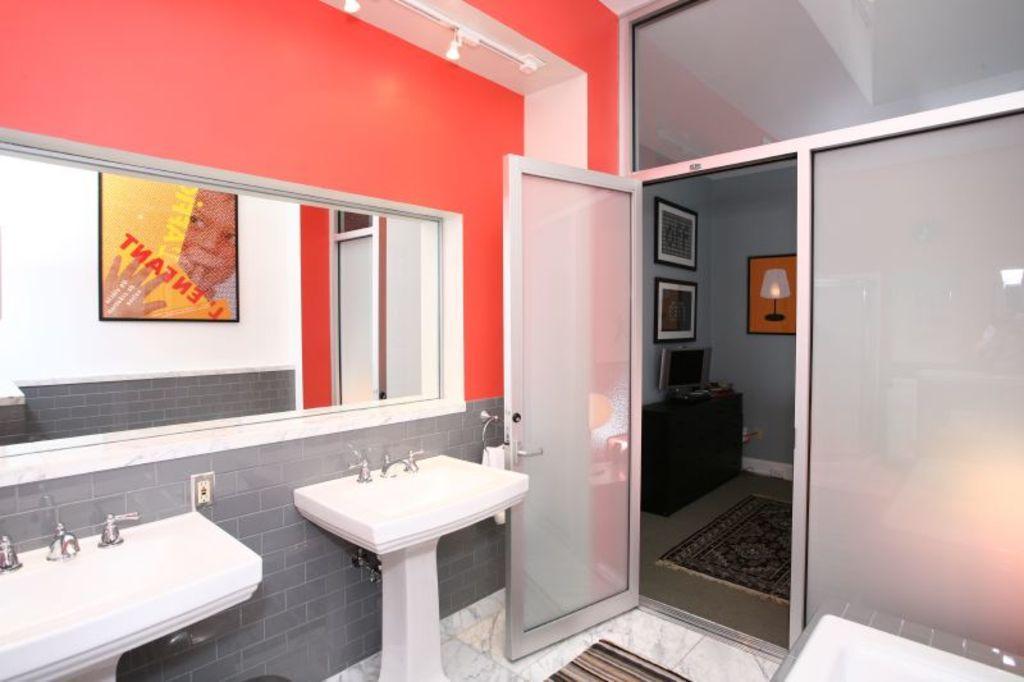Describe this image in one or two sentences. In this picture we can see the wash basin, taps, reflection of a board and the wall. We can see the frames, door, objects, screen, table, towel on a hanger. We can see the door mat and a carpet on the floor. 